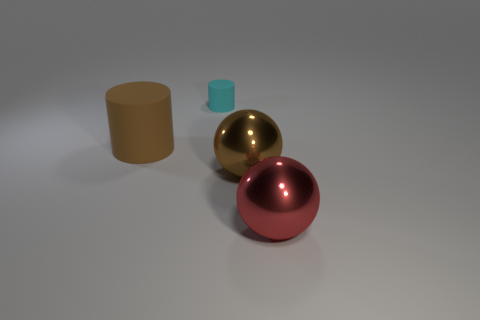Add 2 rubber objects. How many objects exist? 6 Add 2 large brown shiny things. How many large brown shiny things exist? 3 Subtract 0 yellow cubes. How many objects are left? 4 Subtract all brown rubber cylinders. Subtract all cylinders. How many objects are left? 1 Add 1 brown metal things. How many brown metal things are left? 2 